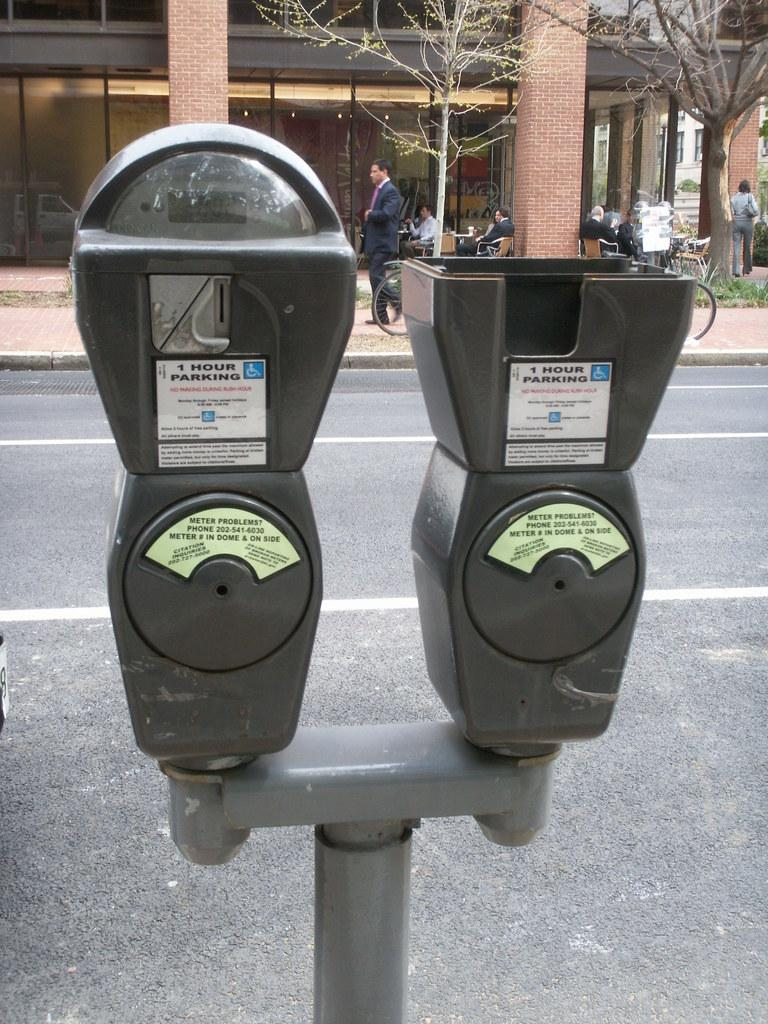<image>
Share a concise interpretation of the image provided. Across from a building, a traffic meter with a large sticker reminds patrons there is no parking during rush hour. 